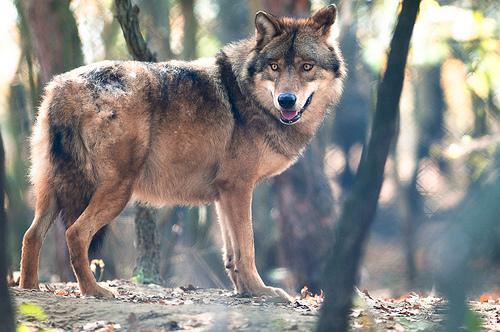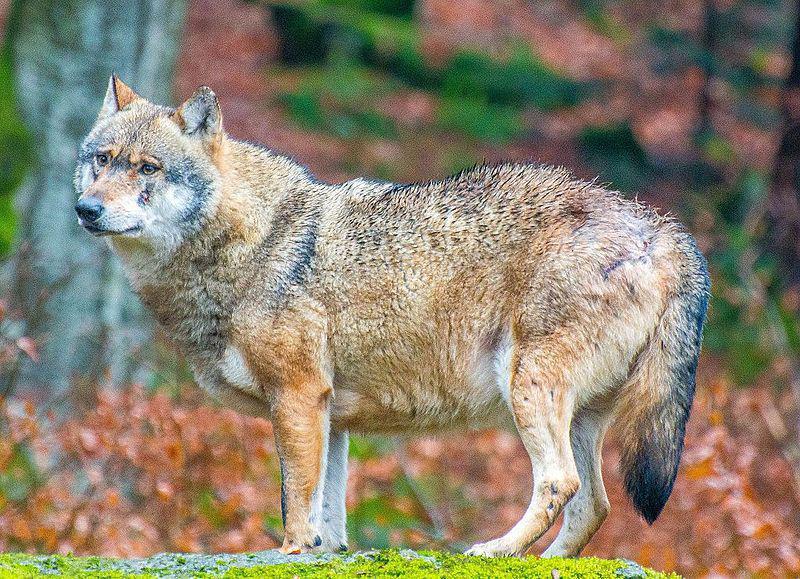The first image is the image on the left, the second image is the image on the right. For the images displayed, is the sentence "Each image contains exactly one wolf, and one image shows a wolf with an open, non-snarling mouth." factually correct? Answer yes or no. Yes. The first image is the image on the left, the second image is the image on the right. Assess this claim about the two images: "At least one wolf is grey and one is tan.". Correct or not? Answer yes or no. No. 